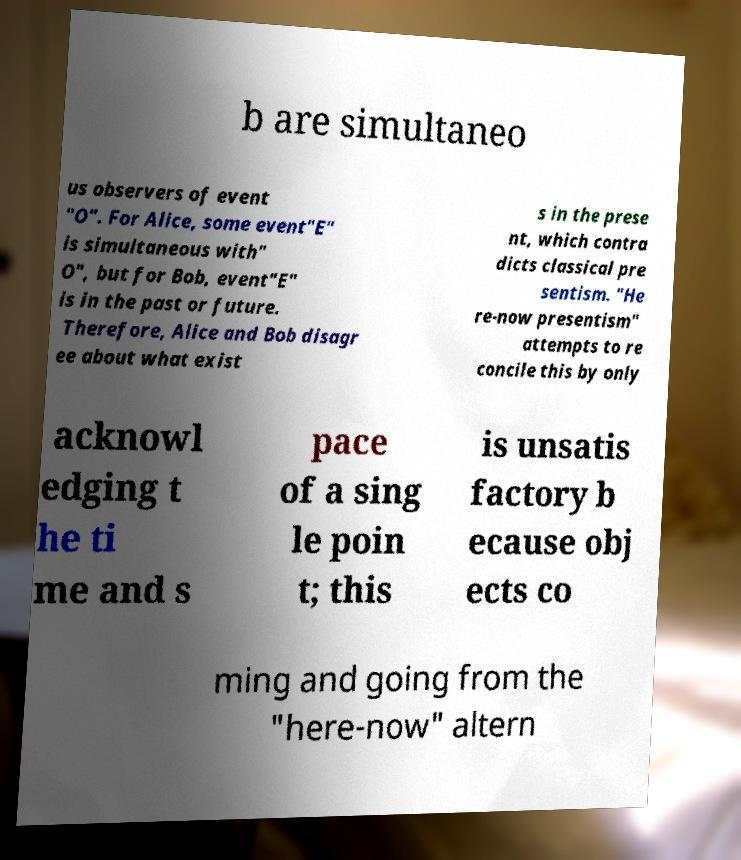Please identify and transcribe the text found in this image. b are simultaneo us observers of event "O". For Alice, some event"E" is simultaneous with" O", but for Bob, event"E" is in the past or future. Therefore, Alice and Bob disagr ee about what exist s in the prese nt, which contra dicts classical pre sentism. "He re-now presentism" attempts to re concile this by only acknowl edging t he ti me and s pace of a sing le poin t; this is unsatis factory b ecause obj ects co ming and going from the "here-now" altern 